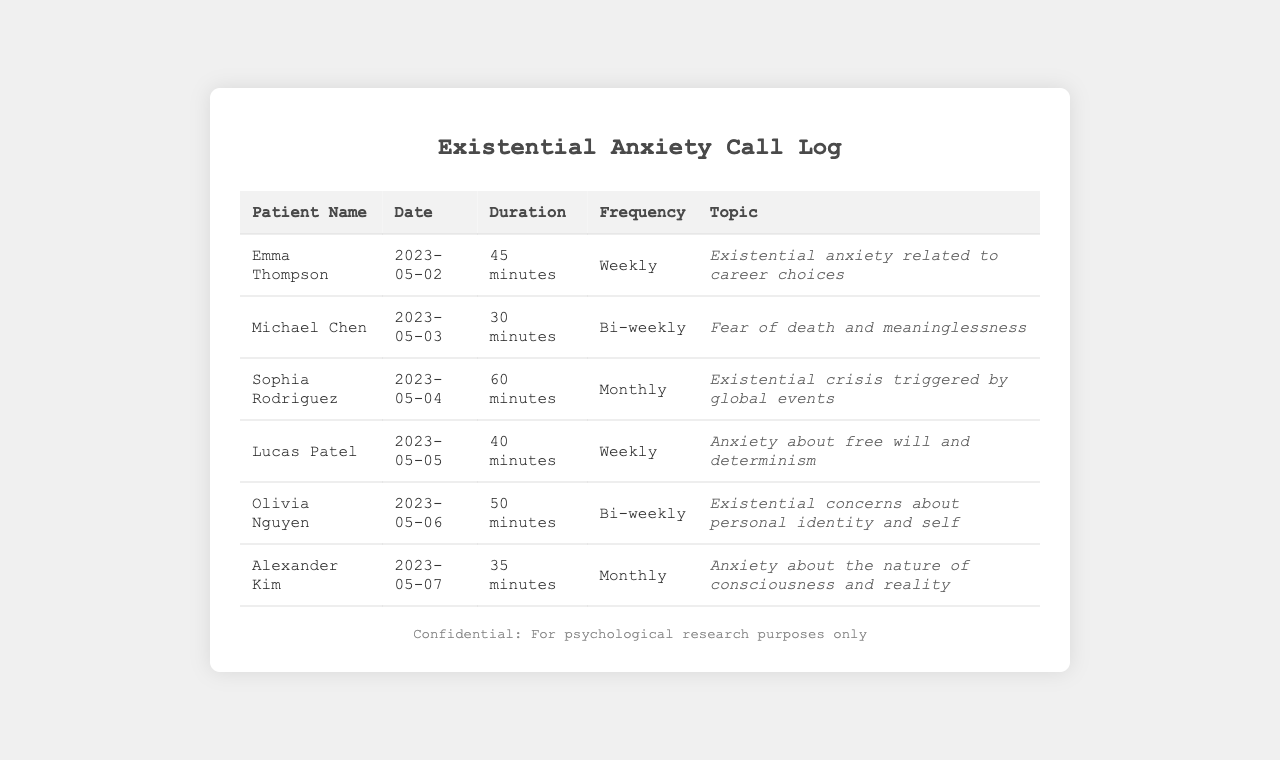What is the name of the patient who discussed career choices? The document provides a list of patient names, and Emma Thompson is associated with career choices in her call log entry.
Answer: Emma Thompson How long was Michael Chen's call? The document includes the duration for each call, and Michael Chen's call lasted for 30 minutes.
Answer: 30 minutes How frequently does Olivia Nguyen have calls? The frequency of calls for each patient is logged, and Olivia Nguyen's calls occur bi-weekly.
Answer: Bi-weekly What existential concern did Lucas Patel express? The topics mentioned in the document reveal that Lucas Patel is anxious about free will and determinism.
Answer: Free will and determinism Which patient had the longest call duration? By comparing the durations in the document, Sophia Rodriguez had the longest call at 60 minutes.
Answer: 60 minutes What was the date of Emma Thompson's call? The call log provides specific dates, and Emma Thompson's call took place on May 2, 2023.
Answer: 2023-05-02 How many patients are discussing existential anxiety on a weekly basis? The document contains multiple entries, and by reviewing, it shows that two patients have weekly discussions.
Answer: 2 What topic was discussed by Alexander Kim? The document specifies that Alexander Kim's discussion revolved around consciousness and reality.
Answer: Nature of consciousness and reality What is the total number of monthly call entries? By counting the frequency of calls logged in the document, there are three patients with monthly entries.
Answer: 3 